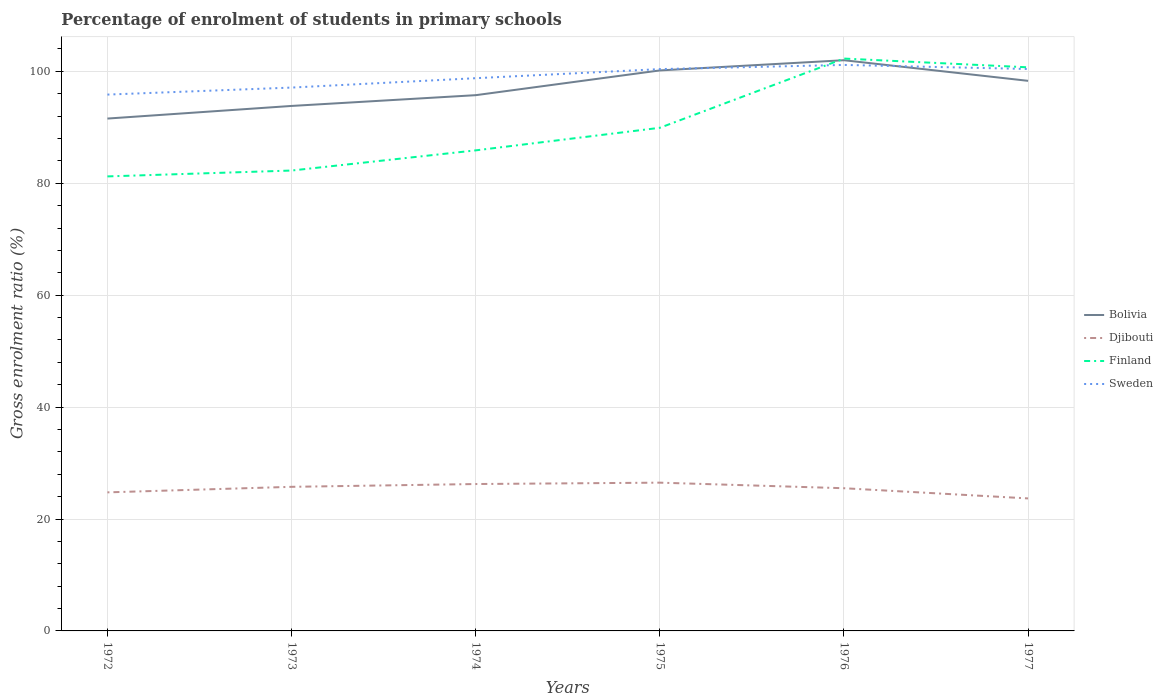How many different coloured lines are there?
Make the answer very short. 4. Across all years, what is the maximum percentage of students enrolled in primary schools in Sweden?
Your response must be concise. 95.85. What is the total percentage of students enrolled in primary schools in Djibouti in the graph?
Offer a terse response. -1.73. What is the difference between the highest and the second highest percentage of students enrolled in primary schools in Finland?
Your answer should be very brief. 21.06. What is the difference between the highest and the lowest percentage of students enrolled in primary schools in Finland?
Give a very brief answer. 2. How many lines are there?
Offer a very short reply. 4. How many years are there in the graph?
Make the answer very short. 6. What is the difference between two consecutive major ticks on the Y-axis?
Provide a succinct answer. 20. Does the graph contain any zero values?
Your answer should be very brief. No. What is the title of the graph?
Give a very brief answer. Percentage of enrolment of students in primary schools. What is the label or title of the X-axis?
Make the answer very short. Years. What is the label or title of the Y-axis?
Your response must be concise. Gross enrolment ratio (%). What is the Gross enrolment ratio (%) in Bolivia in 1972?
Your answer should be very brief. 91.56. What is the Gross enrolment ratio (%) of Djibouti in 1972?
Ensure brevity in your answer.  24.76. What is the Gross enrolment ratio (%) of Finland in 1972?
Provide a short and direct response. 81.23. What is the Gross enrolment ratio (%) in Sweden in 1972?
Your answer should be compact. 95.85. What is the Gross enrolment ratio (%) in Bolivia in 1973?
Offer a very short reply. 93.82. What is the Gross enrolment ratio (%) of Djibouti in 1973?
Ensure brevity in your answer.  25.75. What is the Gross enrolment ratio (%) in Finland in 1973?
Keep it short and to the point. 82.28. What is the Gross enrolment ratio (%) in Sweden in 1973?
Provide a succinct answer. 97.1. What is the Gross enrolment ratio (%) of Bolivia in 1974?
Offer a terse response. 95.74. What is the Gross enrolment ratio (%) of Djibouti in 1974?
Ensure brevity in your answer.  26.25. What is the Gross enrolment ratio (%) of Finland in 1974?
Give a very brief answer. 85.88. What is the Gross enrolment ratio (%) of Sweden in 1974?
Your answer should be compact. 98.78. What is the Gross enrolment ratio (%) of Bolivia in 1975?
Keep it short and to the point. 100.17. What is the Gross enrolment ratio (%) of Djibouti in 1975?
Provide a succinct answer. 26.5. What is the Gross enrolment ratio (%) in Finland in 1975?
Your response must be concise. 89.91. What is the Gross enrolment ratio (%) in Sweden in 1975?
Your response must be concise. 100.4. What is the Gross enrolment ratio (%) of Bolivia in 1976?
Your answer should be compact. 101.99. What is the Gross enrolment ratio (%) in Djibouti in 1976?
Ensure brevity in your answer.  25.5. What is the Gross enrolment ratio (%) of Finland in 1976?
Provide a succinct answer. 102.29. What is the Gross enrolment ratio (%) in Sweden in 1976?
Provide a succinct answer. 101.15. What is the Gross enrolment ratio (%) of Bolivia in 1977?
Give a very brief answer. 98.31. What is the Gross enrolment ratio (%) in Djibouti in 1977?
Offer a very short reply. 23.68. What is the Gross enrolment ratio (%) in Finland in 1977?
Keep it short and to the point. 100.72. What is the Gross enrolment ratio (%) in Sweden in 1977?
Offer a very short reply. 100.42. Across all years, what is the maximum Gross enrolment ratio (%) of Bolivia?
Your response must be concise. 101.99. Across all years, what is the maximum Gross enrolment ratio (%) of Djibouti?
Offer a very short reply. 26.5. Across all years, what is the maximum Gross enrolment ratio (%) in Finland?
Keep it short and to the point. 102.29. Across all years, what is the maximum Gross enrolment ratio (%) of Sweden?
Provide a succinct answer. 101.15. Across all years, what is the minimum Gross enrolment ratio (%) in Bolivia?
Give a very brief answer. 91.56. Across all years, what is the minimum Gross enrolment ratio (%) in Djibouti?
Keep it short and to the point. 23.68. Across all years, what is the minimum Gross enrolment ratio (%) of Finland?
Provide a short and direct response. 81.23. Across all years, what is the minimum Gross enrolment ratio (%) in Sweden?
Your response must be concise. 95.85. What is the total Gross enrolment ratio (%) of Bolivia in the graph?
Keep it short and to the point. 581.59. What is the total Gross enrolment ratio (%) in Djibouti in the graph?
Offer a terse response. 152.44. What is the total Gross enrolment ratio (%) in Finland in the graph?
Offer a terse response. 542.3. What is the total Gross enrolment ratio (%) of Sweden in the graph?
Ensure brevity in your answer.  593.7. What is the difference between the Gross enrolment ratio (%) in Bolivia in 1972 and that in 1973?
Your answer should be very brief. -2.26. What is the difference between the Gross enrolment ratio (%) in Djibouti in 1972 and that in 1973?
Provide a short and direct response. -0.99. What is the difference between the Gross enrolment ratio (%) in Finland in 1972 and that in 1973?
Your answer should be very brief. -1.05. What is the difference between the Gross enrolment ratio (%) of Sweden in 1972 and that in 1973?
Provide a short and direct response. -1.25. What is the difference between the Gross enrolment ratio (%) of Bolivia in 1972 and that in 1974?
Your answer should be compact. -4.18. What is the difference between the Gross enrolment ratio (%) of Djibouti in 1972 and that in 1974?
Ensure brevity in your answer.  -1.49. What is the difference between the Gross enrolment ratio (%) of Finland in 1972 and that in 1974?
Offer a terse response. -4.65. What is the difference between the Gross enrolment ratio (%) in Sweden in 1972 and that in 1974?
Provide a succinct answer. -2.93. What is the difference between the Gross enrolment ratio (%) in Bolivia in 1972 and that in 1975?
Your answer should be very brief. -8.6. What is the difference between the Gross enrolment ratio (%) of Djibouti in 1972 and that in 1975?
Provide a succinct answer. -1.73. What is the difference between the Gross enrolment ratio (%) of Finland in 1972 and that in 1975?
Your answer should be compact. -8.69. What is the difference between the Gross enrolment ratio (%) in Sweden in 1972 and that in 1975?
Keep it short and to the point. -4.55. What is the difference between the Gross enrolment ratio (%) of Bolivia in 1972 and that in 1976?
Make the answer very short. -10.43. What is the difference between the Gross enrolment ratio (%) of Djibouti in 1972 and that in 1976?
Ensure brevity in your answer.  -0.74. What is the difference between the Gross enrolment ratio (%) in Finland in 1972 and that in 1976?
Offer a very short reply. -21.06. What is the difference between the Gross enrolment ratio (%) of Sweden in 1972 and that in 1976?
Give a very brief answer. -5.3. What is the difference between the Gross enrolment ratio (%) in Bolivia in 1972 and that in 1977?
Provide a short and direct response. -6.74. What is the difference between the Gross enrolment ratio (%) in Djibouti in 1972 and that in 1977?
Make the answer very short. 1.08. What is the difference between the Gross enrolment ratio (%) in Finland in 1972 and that in 1977?
Offer a terse response. -19.49. What is the difference between the Gross enrolment ratio (%) in Sweden in 1972 and that in 1977?
Provide a short and direct response. -4.57. What is the difference between the Gross enrolment ratio (%) of Bolivia in 1973 and that in 1974?
Offer a very short reply. -1.92. What is the difference between the Gross enrolment ratio (%) of Djibouti in 1973 and that in 1974?
Ensure brevity in your answer.  -0.5. What is the difference between the Gross enrolment ratio (%) in Finland in 1973 and that in 1974?
Make the answer very short. -3.6. What is the difference between the Gross enrolment ratio (%) of Sweden in 1973 and that in 1974?
Your response must be concise. -1.68. What is the difference between the Gross enrolment ratio (%) in Bolivia in 1973 and that in 1975?
Make the answer very short. -6.35. What is the difference between the Gross enrolment ratio (%) in Djibouti in 1973 and that in 1975?
Provide a succinct answer. -0.74. What is the difference between the Gross enrolment ratio (%) of Finland in 1973 and that in 1975?
Your answer should be very brief. -7.64. What is the difference between the Gross enrolment ratio (%) in Sweden in 1973 and that in 1975?
Make the answer very short. -3.3. What is the difference between the Gross enrolment ratio (%) in Bolivia in 1973 and that in 1976?
Provide a short and direct response. -8.17. What is the difference between the Gross enrolment ratio (%) in Djibouti in 1973 and that in 1976?
Make the answer very short. 0.25. What is the difference between the Gross enrolment ratio (%) in Finland in 1973 and that in 1976?
Give a very brief answer. -20.01. What is the difference between the Gross enrolment ratio (%) in Sweden in 1973 and that in 1976?
Offer a terse response. -4.05. What is the difference between the Gross enrolment ratio (%) in Bolivia in 1973 and that in 1977?
Make the answer very short. -4.49. What is the difference between the Gross enrolment ratio (%) of Djibouti in 1973 and that in 1977?
Your answer should be very brief. 2.07. What is the difference between the Gross enrolment ratio (%) of Finland in 1973 and that in 1977?
Provide a succinct answer. -18.44. What is the difference between the Gross enrolment ratio (%) in Sweden in 1973 and that in 1977?
Provide a succinct answer. -3.32. What is the difference between the Gross enrolment ratio (%) in Bolivia in 1974 and that in 1975?
Your response must be concise. -4.42. What is the difference between the Gross enrolment ratio (%) in Djibouti in 1974 and that in 1975?
Your response must be concise. -0.25. What is the difference between the Gross enrolment ratio (%) in Finland in 1974 and that in 1975?
Offer a terse response. -4.03. What is the difference between the Gross enrolment ratio (%) in Sweden in 1974 and that in 1975?
Ensure brevity in your answer.  -1.62. What is the difference between the Gross enrolment ratio (%) of Bolivia in 1974 and that in 1976?
Provide a succinct answer. -6.25. What is the difference between the Gross enrolment ratio (%) in Djibouti in 1974 and that in 1976?
Provide a short and direct response. 0.75. What is the difference between the Gross enrolment ratio (%) of Finland in 1974 and that in 1976?
Your response must be concise. -16.41. What is the difference between the Gross enrolment ratio (%) in Sweden in 1974 and that in 1976?
Your answer should be very brief. -2.37. What is the difference between the Gross enrolment ratio (%) in Bolivia in 1974 and that in 1977?
Your answer should be very brief. -2.56. What is the difference between the Gross enrolment ratio (%) of Djibouti in 1974 and that in 1977?
Your answer should be very brief. 2.57. What is the difference between the Gross enrolment ratio (%) of Finland in 1974 and that in 1977?
Provide a short and direct response. -14.84. What is the difference between the Gross enrolment ratio (%) in Sweden in 1974 and that in 1977?
Your answer should be very brief. -1.64. What is the difference between the Gross enrolment ratio (%) in Bolivia in 1975 and that in 1976?
Offer a terse response. -1.82. What is the difference between the Gross enrolment ratio (%) of Djibouti in 1975 and that in 1976?
Offer a very short reply. 1. What is the difference between the Gross enrolment ratio (%) in Finland in 1975 and that in 1976?
Give a very brief answer. -12.37. What is the difference between the Gross enrolment ratio (%) in Sweden in 1975 and that in 1976?
Give a very brief answer. -0.75. What is the difference between the Gross enrolment ratio (%) of Bolivia in 1975 and that in 1977?
Your answer should be compact. 1.86. What is the difference between the Gross enrolment ratio (%) in Djibouti in 1975 and that in 1977?
Make the answer very short. 2.82. What is the difference between the Gross enrolment ratio (%) of Finland in 1975 and that in 1977?
Your answer should be compact. -10.81. What is the difference between the Gross enrolment ratio (%) of Sweden in 1975 and that in 1977?
Give a very brief answer. -0.02. What is the difference between the Gross enrolment ratio (%) in Bolivia in 1976 and that in 1977?
Your answer should be very brief. 3.68. What is the difference between the Gross enrolment ratio (%) of Djibouti in 1976 and that in 1977?
Offer a very short reply. 1.82. What is the difference between the Gross enrolment ratio (%) of Finland in 1976 and that in 1977?
Provide a succinct answer. 1.57. What is the difference between the Gross enrolment ratio (%) of Sweden in 1976 and that in 1977?
Provide a short and direct response. 0.73. What is the difference between the Gross enrolment ratio (%) of Bolivia in 1972 and the Gross enrolment ratio (%) of Djibouti in 1973?
Your answer should be very brief. 65.81. What is the difference between the Gross enrolment ratio (%) of Bolivia in 1972 and the Gross enrolment ratio (%) of Finland in 1973?
Your response must be concise. 9.29. What is the difference between the Gross enrolment ratio (%) of Bolivia in 1972 and the Gross enrolment ratio (%) of Sweden in 1973?
Make the answer very short. -5.54. What is the difference between the Gross enrolment ratio (%) of Djibouti in 1972 and the Gross enrolment ratio (%) of Finland in 1973?
Your answer should be compact. -57.51. What is the difference between the Gross enrolment ratio (%) of Djibouti in 1972 and the Gross enrolment ratio (%) of Sweden in 1973?
Offer a very short reply. -72.34. What is the difference between the Gross enrolment ratio (%) of Finland in 1972 and the Gross enrolment ratio (%) of Sweden in 1973?
Your answer should be compact. -15.88. What is the difference between the Gross enrolment ratio (%) in Bolivia in 1972 and the Gross enrolment ratio (%) in Djibouti in 1974?
Make the answer very short. 65.31. What is the difference between the Gross enrolment ratio (%) in Bolivia in 1972 and the Gross enrolment ratio (%) in Finland in 1974?
Your answer should be very brief. 5.68. What is the difference between the Gross enrolment ratio (%) in Bolivia in 1972 and the Gross enrolment ratio (%) in Sweden in 1974?
Give a very brief answer. -7.21. What is the difference between the Gross enrolment ratio (%) in Djibouti in 1972 and the Gross enrolment ratio (%) in Finland in 1974?
Ensure brevity in your answer.  -61.12. What is the difference between the Gross enrolment ratio (%) of Djibouti in 1972 and the Gross enrolment ratio (%) of Sweden in 1974?
Your answer should be very brief. -74.02. What is the difference between the Gross enrolment ratio (%) in Finland in 1972 and the Gross enrolment ratio (%) in Sweden in 1974?
Offer a terse response. -17.55. What is the difference between the Gross enrolment ratio (%) of Bolivia in 1972 and the Gross enrolment ratio (%) of Djibouti in 1975?
Make the answer very short. 65.07. What is the difference between the Gross enrolment ratio (%) in Bolivia in 1972 and the Gross enrolment ratio (%) in Finland in 1975?
Keep it short and to the point. 1.65. What is the difference between the Gross enrolment ratio (%) in Bolivia in 1972 and the Gross enrolment ratio (%) in Sweden in 1975?
Offer a terse response. -8.84. What is the difference between the Gross enrolment ratio (%) in Djibouti in 1972 and the Gross enrolment ratio (%) in Finland in 1975?
Offer a very short reply. -65.15. What is the difference between the Gross enrolment ratio (%) of Djibouti in 1972 and the Gross enrolment ratio (%) of Sweden in 1975?
Keep it short and to the point. -75.64. What is the difference between the Gross enrolment ratio (%) of Finland in 1972 and the Gross enrolment ratio (%) of Sweden in 1975?
Provide a succinct answer. -19.18. What is the difference between the Gross enrolment ratio (%) of Bolivia in 1972 and the Gross enrolment ratio (%) of Djibouti in 1976?
Provide a succinct answer. 66.06. What is the difference between the Gross enrolment ratio (%) in Bolivia in 1972 and the Gross enrolment ratio (%) in Finland in 1976?
Offer a very short reply. -10.72. What is the difference between the Gross enrolment ratio (%) of Bolivia in 1972 and the Gross enrolment ratio (%) of Sweden in 1976?
Your response must be concise. -9.59. What is the difference between the Gross enrolment ratio (%) in Djibouti in 1972 and the Gross enrolment ratio (%) in Finland in 1976?
Provide a short and direct response. -77.52. What is the difference between the Gross enrolment ratio (%) of Djibouti in 1972 and the Gross enrolment ratio (%) of Sweden in 1976?
Give a very brief answer. -76.39. What is the difference between the Gross enrolment ratio (%) in Finland in 1972 and the Gross enrolment ratio (%) in Sweden in 1976?
Provide a succinct answer. -19.92. What is the difference between the Gross enrolment ratio (%) of Bolivia in 1972 and the Gross enrolment ratio (%) of Djibouti in 1977?
Your answer should be very brief. 67.88. What is the difference between the Gross enrolment ratio (%) in Bolivia in 1972 and the Gross enrolment ratio (%) in Finland in 1977?
Offer a terse response. -9.16. What is the difference between the Gross enrolment ratio (%) in Bolivia in 1972 and the Gross enrolment ratio (%) in Sweden in 1977?
Offer a very short reply. -8.86. What is the difference between the Gross enrolment ratio (%) in Djibouti in 1972 and the Gross enrolment ratio (%) in Finland in 1977?
Provide a short and direct response. -75.96. What is the difference between the Gross enrolment ratio (%) of Djibouti in 1972 and the Gross enrolment ratio (%) of Sweden in 1977?
Provide a succinct answer. -75.66. What is the difference between the Gross enrolment ratio (%) of Finland in 1972 and the Gross enrolment ratio (%) of Sweden in 1977?
Keep it short and to the point. -19.2. What is the difference between the Gross enrolment ratio (%) in Bolivia in 1973 and the Gross enrolment ratio (%) in Djibouti in 1974?
Give a very brief answer. 67.57. What is the difference between the Gross enrolment ratio (%) of Bolivia in 1973 and the Gross enrolment ratio (%) of Finland in 1974?
Your response must be concise. 7.94. What is the difference between the Gross enrolment ratio (%) in Bolivia in 1973 and the Gross enrolment ratio (%) in Sweden in 1974?
Provide a short and direct response. -4.96. What is the difference between the Gross enrolment ratio (%) in Djibouti in 1973 and the Gross enrolment ratio (%) in Finland in 1974?
Your response must be concise. -60.13. What is the difference between the Gross enrolment ratio (%) in Djibouti in 1973 and the Gross enrolment ratio (%) in Sweden in 1974?
Make the answer very short. -73.03. What is the difference between the Gross enrolment ratio (%) of Finland in 1973 and the Gross enrolment ratio (%) of Sweden in 1974?
Keep it short and to the point. -16.5. What is the difference between the Gross enrolment ratio (%) of Bolivia in 1973 and the Gross enrolment ratio (%) of Djibouti in 1975?
Offer a terse response. 67.32. What is the difference between the Gross enrolment ratio (%) of Bolivia in 1973 and the Gross enrolment ratio (%) of Finland in 1975?
Make the answer very short. 3.91. What is the difference between the Gross enrolment ratio (%) of Bolivia in 1973 and the Gross enrolment ratio (%) of Sweden in 1975?
Keep it short and to the point. -6.58. What is the difference between the Gross enrolment ratio (%) of Djibouti in 1973 and the Gross enrolment ratio (%) of Finland in 1975?
Your answer should be compact. -64.16. What is the difference between the Gross enrolment ratio (%) of Djibouti in 1973 and the Gross enrolment ratio (%) of Sweden in 1975?
Provide a short and direct response. -74.65. What is the difference between the Gross enrolment ratio (%) of Finland in 1973 and the Gross enrolment ratio (%) of Sweden in 1975?
Make the answer very short. -18.13. What is the difference between the Gross enrolment ratio (%) in Bolivia in 1973 and the Gross enrolment ratio (%) in Djibouti in 1976?
Give a very brief answer. 68.32. What is the difference between the Gross enrolment ratio (%) in Bolivia in 1973 and the Gross enrolment ratio (%) in Finland in 1976?
Your answer should be compact. -8.47. What is the difference between the Gross enrolment ratio (%) in Bolivia in 1973 and the Gross enrolment ratio (%) in Sweden in 1976?
Your response must be concise. -7.33. What is the difference between the Gross enrolment ratio (%) in Djibouti in 1973 and the Gross enrolment ratio (%) in Finland in 1976?
Your answer should be compact. -76.53. What is the difference between the Gross enrolment ratio (%) in Djibouti in 1973 and the Gross enrolment ratio (%) in Sweden in 1976?
Your answer should be compact. -75.4. What is the difference between the Gross enrolment ratio (%) in Finland in 1973 and the Gross enrolment ratio (%) in Sweden in 1976?
Make the answer very short. -18.87. What is the difference between the Gross enrolment ratio (%) of Bolivia in 1973 and the Gross enrolment ratio (%) of Djibouti in 1977?
Provide a succinct answer. 70.14. What is the difference between the Gross enrolment ratio (%) of Bolivia in 1973 and the Gross enrolment ratio (%) of Finland in 1977?
Give a very brief answer. -6.9. What is the difference between the Gross enrolment ratio (%) in Bolivia in 1973 and the Gross enrolment ratio (%) in Sweden in 1977?
Provide a succinct answer. -6.6. What is the difference between the Gross enrolment ratio (%) of Djibouti in 1973 and the Gross enrolment ratio (%) of Finland in 1977?
Provide a short and direct response. -74.97. What is the difference between the Gross enrolment ratio (%) in Djibouti in 1973 and the Gross enrolment ratio (%) in Sweden in 1977?
Offer a terse response. -74.67. What is the difference between the Gross enrolment ratio (%) of Finland in 1973 and the Gross enrolment ratio (%) of Sweden in 1977?
Offer a terse response. -18.15. What is the difference between the Gross enrolment ratio (%) of Bolivia in 1974 and the Gross enrolment ratio (%) of Djibouti in 1975?
Your answer should be very brief. 69.25. What is the difference between the Gross enrolment ratio (%) in Bolivia in 1974 and the Gross enrolment ratio (%) in Finland in 1975?
Offer a very short reply. 5.83. What is the difference between the Gross enrolment ratio (%) in Bolivia in 1974 and the Gross enrolment ratio (%) in Sweden in 1975?
Your response must be concise. -4.66. What is the difference between the Gross enrolment ratio (%) in Djibouti in 1974 and the Gross enrolment ratio (%) in Finland in 1975?
Your response must be concise. -63.66. What is the difference between the Gross enrolment ratio (%) of Djibouti in 1974 and the Gross enrolment ratio (%) of Sweden in 1975?
Give a very brief answer. -74.15. What is the difference between the Gross enrolment ratio (%) in Finland in 1974 and the Gross enrolment ratio (%) in Sweden in 1975?
Give a very brief answer. -14.52. What is the difference between the Gross enrolment ratio (%) in Bolivia in 1974 and the Gross enrolment ratio (%) in Djibouti in 1976?
Your response must be concise. 70.24. What is the difference between the Gross enrolment ratio (%) of Bolivia in 1974 and the Gross enrolment ratio (%) of Finland in 1976?
Your answer should be compact. -6.54. What is the difference between the Gross enrolment ratio (%) in Bolivia in 1974 and the Gross enrolment ratio (%) in Sweden in 1976?
Your answer should be compact. -5.41. What is the difference between the Gross enrolment ratio (%) of Djibouti in 1974 and the Gross enrolment ratio (%) of Finland in 1976?
Your response must be concise. -76.03. What is the difference between the Gross enrolment ratio (%) of Djibouti in 1974 and the Gross enrolment ratio (%) of Sweden in 1976?
Your answer should be compact. -74.9. What is the difference between the Gross enrolment ratio (%) of Finland in 1974 and the Gross enrolment ratio (%) of Sweden in 1976?
Provide a short and direct response. -15.27. What is the difference between the Gross enrolment ratio (%) of Bolivia in 1974 and the Gross enrolment ratio (%) of Djibouti in 1977?
Your answer should be very brief. 72.06. What is the difference between the Gross enrolment ratio (%) of Bolivia in 1974 and the Gross enrolment ratio (%) of Finland in 1977?
Your answer should be compact. -4.98. What is the difference between the Gross enrolment ratio (%) in Bolivia in 1974 and the Gross enrolment ratio (%) in Sweden in 1977?
Your response must be concise. -4.68. What is the difference between the Gross enrolment ratio (%) of Djibouti in 1974 and the Gross enrolment ratio (%) of Finland in 1977?
Make the answer very short. -74.47. What is the difference between the Gross enrolment ratio (%) in Djibouti in 1974 and the Gross enrolment ratio (%) in Sweden in 1977?
Your answer should be very brief. -74.17. What is the difference between the Gross enrolment ratio (%) in Finland in 1974 and the Gross enrolment ratio (%) in Sweden in 1977?
Your answer should be compact. -14.54. What is the difference between the Gross enrolment ratio (%) of Bolivia in 1975 and the Gross enrolment ratio (%) of Djibouti in 1976?
Make the answer very short. 74.67. What is the difference between the Gross enrolment ratio (%) in Bolivia in 1975 and the Gross enrolment ratio (%) in Finland in 1976?
Keep it short and to the point. -2.12. What is the difference between the Gross enrolment ratio (%) in Bolivia in 1975 and the Gross enrolment ratio (%) in Sweden in 1976?
Ensure brevity in your answer.  -0.98. What is the difference between the Gross enrolment ratio (%) of Djibouti in 1975 and the Gross enrolment ratio (%) of Finland in 1976?
Provide a succinct answer. -75.79. What is the difference between the Gross enrolment ratio (%) of Djibouti in 1975 and the Gross enrolment ratio (%) of Sweden in 1976?
Ensure brevity in your answer.  -74.65. What is the difference between the Gross enrolment ratio (%) in Finland in 1975 and the Gross enrolment ratio (%) in Sweden in 1976?
Make the answer very short. -11.24. What is the difference between the Gross enrolment ratio (%) in Bolivia in 1975 and the Gross enrolment ratio (%) in Djibouti in 1977?
Your answer should be compact. 76.49. What is the difference between the Gross enrolment ratio (%) in Bolivia in 1975 and the Gross enrolment ratio (%) in Finland in 1977?
Keep it short and to the point. -0.55. What is the difference between the Gross enrolment ratio (%) in Bolivia in 1975 and the Gross enrolment ratio (%) in Sweden in 1977?
Provide a succinct answer. -0.26. What is the difference between the Gross enrolment ratio (%) in Djibouti in 1975 and the Gross enrolment ratio (%) in Finland in 1977?
Make the answer very short. -74.22. What is the difference between the Gross enrolment ratio (%) in Djibouti in 1975 and the Gross enrolment ratio (%) in Sweden in 1977?
Offer a terse response. -73.93. What is the difference between the Gross enrolment ratio (%) of Finland in 1975 and the Gross enrolment ratio (%) of Sweden in 1977?
Keep it short and to the point. -10.51. What is the difference between the Gross enrolment ratio (%) of Bolivia in 1976 and the Gross enrolment ratio (%) of Djibouti in 1977?
Your response must be concise. 78.31. What is the difference between the Gross enrolment ratio (%) in Bolivia in 1976 and the Gross enrolment ratio (%) in Finland in 1977?
Your response must be concise. 1.27. What is the difference between the Gross enrolment ratio (%) of Bolivia in 1976 and the Gross enrolment ratio (%) of Sweden in 1977?
Your answer should be very brief. 1.57. What is the difference between the Gross enrolment ratio (%) of Djibouti in 1976 and the Gross enrolment ratio (%) of Finland in 1977?
Your response must be concise. -75.22. What is the difference between the Gross enrolment ratio (%) of Djibouti in 1976 and the Gross enrolment ratio (%) of Sweden in 1977?
Keep it short and to the point. -74.92. What is the difference between the Gross enrolment ratio (%) of Finland in 1976 and the Gross enrolment ratio (%) of Sweden in 1977?
Offer a very short reply. 1.86. What is the average Gross enrolment ratio (%) of Bolivia per year?
Your answer should be very brief. 96.93. What is the average Gross enrolment ratio (%) of Djibouti per year?
Keep it short and to the point. 25.41. What is the average Gross enrolment ratio (%) of Finland per year?
Offer a very short reply. 90.38. What is the average Gross enrolment ratio (%) in Sweden per year?
Provide a short and direct response. 98.95. In the year 1972, what is the difference between the Gross enrolment ratio (%) in Bolivia and Gross enrolment ratio (%) in Djibouti?
Provide a succinct answer. 66.8. In the year 1972, what is the difference between the Gross enrolment ratio (%) of Bolivia and Gross enrolment ratio (%) of Finland?
Your response must be concise. 10.34. In the year 1972, what is the difference between the Gross enrolment ratio (%) in Bolivia and Gross enrolment ratio (%) in Sweden?
Offer a terse response. -4.28. In the year 1972, what is the difference between the Gross enrolment ratio (%) of Djibouti and Gross enrolment ratio (%) of Finland?
Provide a short and direct response. -56.46. In the year 1972, what is the difference between the Gross enrolment ratio (%) in Djibouti and Gross enrolment ratio (%) in Sweden?
Provide a short and direct response. -71.09. In the year 1972, what is the difference between the Gross enrolment ratio (%) of Finland and Gross enrolment ratio (%) of Sweden?
Give a very brief answer. -14.62. In the year 1973, what is the difference between the Gross enrolment ratio (%) in Bolivia and Gross enrolment ratio (%) in Djibouti?
Offer a terse response. 68.07. In the year 1973, what is the difference between the Gross enrolment ratio (%) in Bolivia and Gross enrolment ratio (%) in Finland?
Provide a short and direct response. 11.54. In the year 1973, what is the difference between the Gross enrolment ratio (%) in Bolivia and Gross enrolment ratio (%) in Sweden?
Give a very brief answer. -3.28. In the year 1973, what is the difference between the Gross enrolment ratio (%) of Djibouti and Gross enrolment ratio (%) of Finland?
Keep it short and to the point. -56.52. In the year 1973, what is the difference between the Gross enrolment ratio (%) in Djibouti and Gross enrolment ratio (%) in Sweden?
Your answer should be compact. -71.35. In the year 1973, what is the difference between the Gross enrolment ratio (%) in Finland and Gross enrolment ratio (%) in Sweden?
Your answer should be compact. -14.83. In the year 1974, what is the difference between the Gross enrolment ratio (%) in Bolivia and Gross enrolment ratio (%) in Djibouti?
Offer a terse response. 69.49. In the year 1974, what is the difference between the Gross enrolment ratio (%) in Bolivia and Gross enrolment ratio (%) in Finland?
Ensure brevity in your answer.  9.86. In the year 1974, what is the difference between the Gross enrolment ratio (%) in Bolivia and Gross enrolment ratio (%) in Sweden?
Give a very brief answer. -3.03. In the year 1974, what is the difference between the Gross enrolment ratio (%) of Djibouti and Gross enrolment ratio (%) of Finland?
Your answer should be very brief. -59.63. In the year 1974, what is the difference between the Gross enrolment ratio (%) of Djibouti and Gross enrolment ratio (%) of Sweden?
Make the answer very short. -72.53. In the year 1974, what is the difference between the Gross enrolment ratio (%) in Finland and Gross enrolment ratio (%) in Sweden?
Make the answer very short. -12.9. In the year 1975, what is the difference between the Gross enrolment ratio (%) in Bolivia and Gross enrolment ratio (%) in Djibouti?
Offer a terse response. 73.67. In the year 1975, what is the difference between the Gross enrolment ratio (%) of Bolivia and Gross enrolment ratio (%) of Finland?
Give a very brief answer. 10.25. In the year 1975, what is the difference between the Gross enrolment ratio (%) of Bolivia and Gross enrolment ratio (%) of Sweden?
Your answer should be compact. -0.23. In the year 1975, what is the difference between the Gross enrolment ratio (%) in Djibouti and Gross enrolment ratio (%) in Finland?
Offer a very short reply. -63.42. In the year 1975, what is the difference between the Gross enrolment ratio (%) in Djibouti and Gross enrolment ratio (%) in Sweden?
Give a very brief answer. -73.91. In the year 1975, what is the difference between the Gross enrolment ratio (%) in Finland and Gross enrolment ratio (%) in Sweden?
Your answer should be compact. -10.49. In the year 1976, what is the difference between the Gross enrolment ratio (%) of Bolivia and Gross enrolment ratio (%) of Djibouti?
Your answer should be very brief. 76.49. In the year 1976, what is the difference between the Gross enrolment ratio (%) of Bolivia and Gross enrolment ratio (%) of Finland?
Give a very brief answer. -0.3. In the year 1976, what is the difference between the Gross enrolment ratio (%) of Bolivia and Gross enrolment ratio (%) of Sweden?
Keep it short and to the point. 0.84. In the year 1976, what is the difference between the Gross enrolment ratio (%) in Djibouti and Gross enrolment ratio (%) in Finland?
Provide a succinct answer. -76.79. In the year 1976, what is the difference between the Gross enrolment ratio (%) in Djibouti and Gross enrolment ratio (%) in Sweden?
Ensure brevity in your answer.  -75.65. In the year 1976, what is the difference between the Gross enrolment ratio (%) in Finland and Gross enrolment ratio (%) in Sweden?
Provide a short and direct response. 1.14. In the year 1977, what is the difference between the Gross enrolment ratio (%) of Bolivia and Gross enrolment ratio (%) of Djibouti?
Ensure brevity in your answer.  74.63. In the year 1977, what is the difference between the Gross enrolment ratio (%) in Bolivia and Gross enrolment ratio (%) in Finland?
Keep it short and to the point. -2.41. In the year 1977, what is the difference between the Gross enrolment ratio (%) of Bolivia and Gross enrolment ratio (%) of Sweden?
Your answer should be very brief. -2.12. In the year 1977, what is the difference between the Gross enrolment ratio (%) of Djibouti and Gross enrolment ratio (%) of Finland?
Your answer should be compact. -77.04. In the year 1977, what is the difference between the Gross enrolment ratio (%) of Djibouti and Gross enrolment ratio (%) of Sweden?
Make the answer very short. -76.74. In the year 1977, what is the difference between the Gross enrolment ratio (%) in Finland and Gross enrolment ratio (%) in Sweden?
Provide a short and direct response. 0.3. What is the ratio of the Gross enrolment ratio (%) in Djibouti in 1972 to that in 1973?
Give a very brief answer. 0.96. What is the ratio of the Gross enrolment ratio (%) in Finland in 1972 to that in 1973?
Provide a succinct answer. 0.99. What is the ratio of the Gross enrolment ratio (%) in Sweden in 1972 to that in 1973?
Offer a terse response. 0.99. What is the ratio of the Gross enrolment ratio (%) in Bolivia in 1972 to that in 1974?
Offer a terse response. 0.96. What is the ratio of the Gross enrolment ratio (%) in Djibouti in 1972 to that in 1974?
Ensure brevity in your answer.  0.94. What is the ratio of the Gross enrolment ratio (%) in Finland in 1972 to that in 1974?
Keep it short and to the point. 0.95. What is the ratio of the Gross enrolment ratio (%) of Sweden in 1972 to that in 1974?
Your answer should be compact. 0.97. What is the ratio of the Gross enrolment ratio (%) of Bolivia in 1972 to that in 1975?
Your answer should be very brief. 0.91. What is the ratio of the Gross enrolment ratio (%) of Djibouti in 1972 to that in 1975?
Give a very brief answer. 0.93. What is the ratio of the Gross enrolment ratio (%) in Finland in 1972 to that in 1975?
Offer a terse response. 0.9. What is the ratio of the Gross enrolment ratio (%) of Sweden in 1972 to that in 1975?
Your answer should be very brief. 0.95. What is the ratio of the Gross enrolment ratio (%) of Bolivia in 1972 to that in 1976?
Ensure brevity in your answer.  0.9. What is the ratio of the Gross enrolment ratio (%) in Djibouti in 1972 to that in 1976?
Offer a terse response. 0.97. What is the ratio of the Gross enrolment ratio (%) of Finland in 1972 to that in 1976?
Make the answer very short. 0.79. What is the ratio of the Gross enrolment ratio (%) in Sweden in 1972 to that in 1976?
Your answer should be compact. 0.95. What is the ratio of the Gross enrolment ratio (%) in Bolivia in 1972 to that in 1977?
Give a very brief answer. 0.93. What is the ratio of the Gross enrolment ratio (%) of Djibouti in 1972 to that in 1977?
Offer a terse response. 1.05. What is the ratio of the Gross enrolment ratio (%) of Finland in 1972 to that in 1977?
Your answer should be very brief. 0.81. What is the ratio of the Gross enrolment ratio (%) of Sweden in 1972 to that in 1977?
Keep it short and to the point. 0.95. What is the ratio of the Gross enrolment ratio (%) in Bolivia in 1973 to that in 1974?
Offer a terse response. 0.98. What is the ratio of the Gross enrolment ratio (%) of Finland in 1973 to that in 1974?
Offer a very short reply. 0.96. What is the ratio of the Gross enrolment ratio (%) of Bolivia in 1973 to that in 1975?
Provide a succinct answer. 0.94. What is the ratio of the Gross enrolment ratio (%) of Djibouti in 1973 to that in 1975?
Offer a terse response. 0.97. What is the ratio of the Gross enrolment ratio (%) in Finland in 1973 to that in 1975?
Offer a terse response. 0.92. What is the ratio of the Gross enrolment ratio (%) in Sweden in 1973 to that in 1975?
Make the answer very short. 0.97. What is the ratio of the Gross enrolment ratio (%) of Bolivia in 1973 to that in 1976?
Your answer should be compact. 0.92. What is the ratio of the Gross enrolment ratio (%) in Djibouti in 1973 to that in 1976?
Make the answer very short. 1.01. What is the ratio of the Gross enrolment ratio (%) of Finland in 1973 to that in 1976?
Offer a terse response. 0.8. What is the ratio of the Gross enrolment ratio (%) of Bolivia in 1973 to that in 1977?
Give a very brief answer. 0.95. What is the ratio of the Gross enrolment ratio (%) in Djibouti in 1973 to that in 1977?
Your response must be concise. 1.09. What is the ratio of the Gross enrolment ratio (%) of Finland in 1973 to that in 1977?
Your answer should be compact. 0.82. What is the ratio of the Gross enrolment ratio (%) of Sweden in 1973 to that in 1977?
Keep it short and to the point. 0.97. What is the ratio of the Gross enrolment ratio (%) in Bolivia in 1974 to that in 1975?
Offer a very short reply. 0.96. What is the ratio of the Gross enrolment ratio (%) of Djibouti in 1974 to that in 1975?
Offer a terse response. 0.99. What is the ratio of the Gross enrolment ratio (%) in Finland in 1974 to that in 1975?
Your answer should be compact. 0.96. What is the ratio of the Gross enrolment ratio (%) of Sweden in 1974 to that in 1975?
Your answer should be compact. 0.98. What is the ratio of the Gross enrolment ratio (%) in Bolivia in 1974 to that in 1976?
Your answer should be very brief. 0.94. What is the ratio of the Gross enrolment ratio (%) in Djibouti in 1974 to that in 1976?
Your answer should be compact. 1.03. What is the ratio of the Gross enrolment ratio (%) of Finland in 1974 to that in 1976?
Ensure brevity in your answer.  0.84. What is the ratio of the Gross enrolment ratio (%) of Sweden in 1974 to that in 1976?
Your response must be concise. 0.98. What is the ratio of the Gross enrolment ratio (%) in Bolivia in 1974 to that in 1977?
Your answer should be compact. 0.97. What is the ratio of the Gross enrolment ratio (%) in Djibouti in 1974 to that in 1977?
Keep it short and to the point. 1.11. What is the ratio of the Gross enrolment ratio (%) in Finland in 1974 to that in 1977?
Give a very brief answer. 0.85. What is the ratio of the Gross enrolment ratio (%) in Sweden in 1974 to that in 1977?
Provide a succinct answer. 0.98. What is the ratio of the Gross enrolment ratio (%) of Bolivia in 1975 to that in 1976?
Ensure brevity in your answer.  0.98. What is the ratio of the Gross enrolment ratio (%) of Djibouti in 1975 to that in 1976?
Your answer should be very brief. 1.04. What is the ratio of the Gross enrolment ratio (%) of Finland in 1975 to that in 1976?
Make the answer very short. 0.88. What is the ratio of the Gross enrolment ratio (%) in Sweden in 1975 to that in 1976?
Your answer should be compact. 0.99. What is the ratio of the Gross enrolment ratio (%) of Bolivia in 1975 to that in 1977?
Keep it short and to the point. 1.02. What is the ratio of the Gross enrolment ratio (%) in Djibouti in 1975 to that in 1977?
Your response must be concise. 1.12. What is the ratio of the Gross enrolment ratio (%) of Finland in 1975 to that in 1977?
Offer a terse response. 0.89. What is the ratio of the Gross enrolment ratio (%) in Bolivia in 1976 to that in 1977?
Provide a succinct answer. 1.04. What is the ratio of the Gross enrolment ratio (%) in Djibouti in 1976 to that in 1977?
Keep it short and to the point. 1.08. What is the ratio of the Gross enrolment ratio (%) in Finland in 1976 to that in 1977?
Ensure brevity in your answer.  1.02. What is the ratio of the Gross enrolment ratio (%) of Sweden in 1976 to that in 1977?
Give a very brief answer. 1.01. What is the difference between the highest and the second highest Gross enrolment ratio (%) in Bolivia?
Give a very brief answer. 1.82. What is the difference between the highest and the second highest Gross enrolment ratio (%) in Djibouti?
Your answer should be compact. 0.25. What is the difference between the highest and the second highest Gross enrolment ratio (%) in Finland?
Keep it short and to the point. 1.57. What is the difference between the highest and the second highest Gross enrolment ratio (%) of Sweden?
Your answer should be compact. 0.73. What is the difference between the highest and the lowest Gross enrolment ratio (%) of Bolivia?
Make the answer very short. 10.43. What is the difference between the highest and the lowest Gross enrolment ratio (%) of Djibouti?
Provide a short and direct response. 2.82. What is the difference between the highest and the lowest Gross enrolment ratio (%) in Finland?
Make the answer very short. 21.06. What is the difference between the highest and the lowest Gross enrolment ratio (%) in Sweden?
Provide a succinct answer. 5.3. 